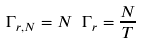<formula> <loc_0><loc_0><loc_500><loc_500>\Gamma _ { r , N } = N \ \Gamma _ { r } = \frac { N } { T }</formula> 